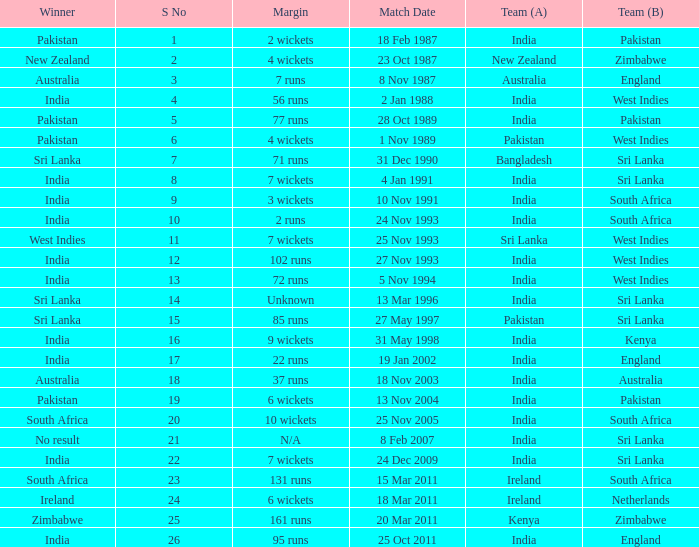Who won the match when the margin was 131 runs? South Africa. 